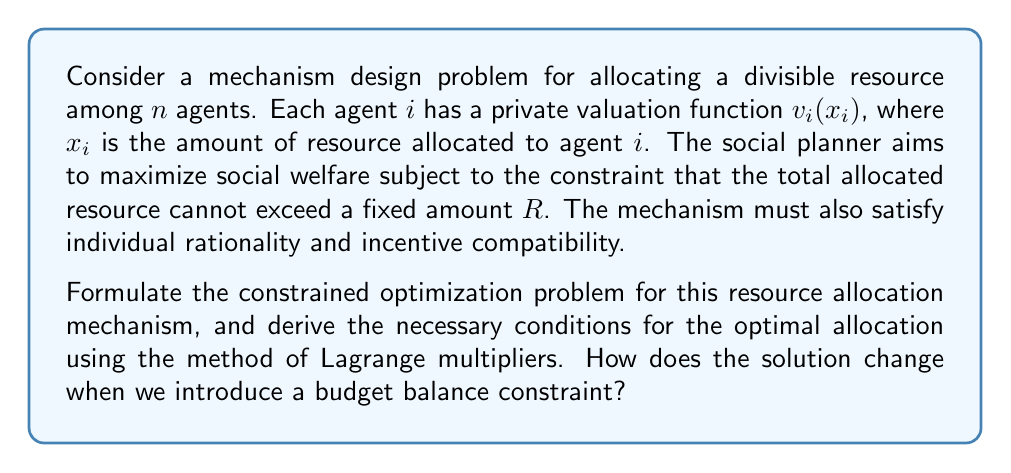Solve this math problem. Let's approach this problem step by step:

1) First, we formulate the constrained optimization problem:

   Maximize: $\sum_{i=1}^n v_i(x_i)$
   Subject to: $\sum_{i=1}^n x_i \leq R$
               $x_i \geq 0$ for all $i$

2) To ensure incentive compatibility, we need to use the revelation principle and work with the direct mechanism. Let $\hat{v}_i$ be the reported valuation function of agent $i$. The mechanism must satisfy:

   $v_i(x_i(\hat{v}_i, \hat{v}_{-i})) - t_i(\hat{v}_i, \hat{v}_{-i}) \geq v_i(x_i(\hat{v}'_i, \hat{v}_{-i})) - t_i(\hat{v}'_i, \hat{v}_{-i})$

   for all $\hat{v}'_i$, where $t_i$ is the transfer function.

3) For individual rationality, we need:

   $v_i(x_i(\hat{v}_i, \hat{v}_{-i})) - t_i(\hat{v}_i, \hat{v}_{-i}) \geq 0$

4) Now, let's solve the optimal allocation problem using Lagrange multipliers. The Lagrangian is:

   $L = \sum_{i=1}^n v_i(x_i) + \lambda(R - \sum_{i=1}^n x_i)$

5) The necessary conditions for optimality are:

   $\frac{\partial L}{\partial x_i} = v'_i(x_i) - \lambda = 0$ for all $i$
   $\lambda(R - \sum_{i=1}^n x_i) = 0$
   $\lambda \geq 0$

6) From these conditions, we can deduce that at the optimal solution:

   $v'_1(x_1) = v'_2(x_2) = ... = v'_n(x_n) = \lambda$

   This means that the marginal valuations of all agents should be equalized at the optimal allocation.

7) If we introduce a budget balance constraint, i.e., $\sum_{i=1}^n t_i = 0$, the problem becomes more complex. This additional constraint often leads to impossibility results in mechanism design, as shown by the Myerson-Satterthwaite theorem.

8) With budget balance, we need to modify our Lagrangian:

   $L = \sum_{i=1}^n v_i(x_i) + \lambda(R - \sum_{i=1}^n x_i) + \mu(\sum_{i=1}^n t_i)$

   Where $\mu$ is the Lagrange multiplier for the budget balance constraint.

9) The new necessary conditions will include terms involving the transfers $t_i$, making the problem significantly more challenging to solve explicitly.
Answer: The optimal allocation satisfies $v'_1(x_1) = v'_2(x_2) = ... = v'_n(x_n) = \lambda$, where $\lambda$ is the Lagrange multiplier for the resource constraint. This equalizes marginal valuations across all agents. Adding a budget balance constraint complicates the problem, often leading to impossibility results, and requires considering transfer payments in the optimization conditions. 